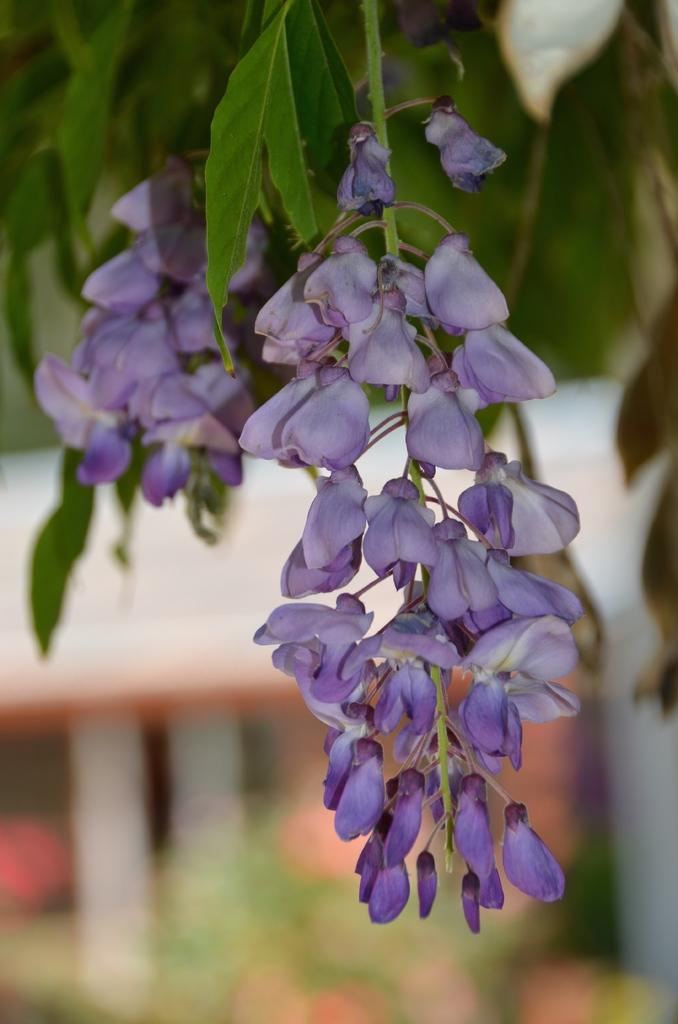What type of plants can be seen in the image? There are flowers in the image. What color are the flowers? The flowers are purple in color. Are there any other parts of the plants visible in the image? Yes, there are leaves associated with the flowers. How would you describe the background of the image? The background of the image is blurred. What flavor of ice cream is the fireman eating in the image? There is no fireman or ice cream present in the image; it features flowers with leaves and a blurred background. 